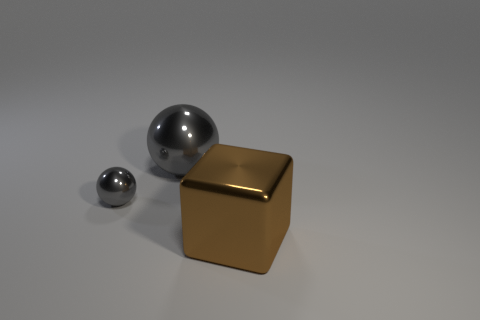How many things have the same color as the big ball?
Your answer should be compact. 1. What material is the other sphere that is the same color as the tiny ball?
Your answer should be very brief. Metal. Are there more large gray objects behind the large gray object than large cyan blocks?
Offer a very short reply. No. Is the shape of the small gray thing the same as the big brown object?
Your response must be concise. No. How many gray spheres have the same material as the tiny gray thing?
Offer a very short reply. 1. There is another gray shiny object that is the same shape as the small gray object; what size is it?
Keep it short and to the point. Large. The big metallic object in front of the big object behind the shiny object to the right of the big metal ball is what shape?
Your answer should be compact. Cube. The other metal thing that is the same shape as the large gray object is what color?
Offer a terse response. Gray. There is a shiny object that is on the right side of the small metallic ball and behind the big brown cube; what size is it?
Your answer should be compact. Large. How many large objects are behind the gray metallic ball that is in front of the ball behind the tiny gray metal thing?
Your answer should be compact. 1. 